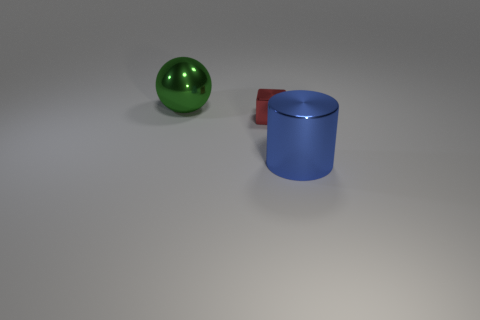Add 3 big metal cylinders. How many objects exist? 6 Subtract all cylinders. How many objects are left? 2 Add 1 shiny cylinders. How many shiny cylinders exist? 2 Subtract 0 blue cubes. How many objects are left? 3 Subtract all cylinders. Subtract all brown objects. How many objects are left? 2 Add 2 blue cylinders. How many blue cylinders are left? 3 